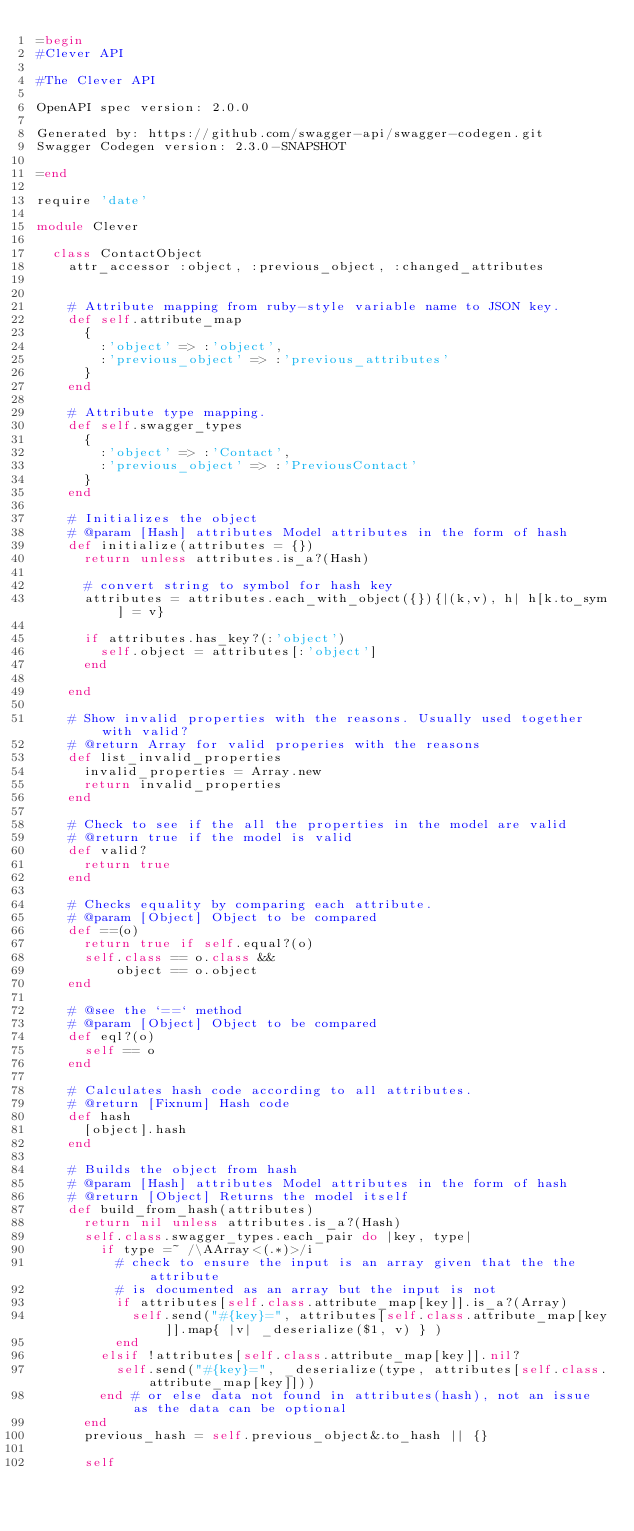<code> <loc_0><loc_0><loc_500><loc_500><_Ruby_>=begin
#Clever API

#The Clever API

OpenAPI spec version: 2.0.0

Generated by: https://github.com/swagger-api/swagger-codegen.git
Swagger Codegen version: 2.3.0-SNAPSHOT

=end

require 'date'

module Clever

  class ContactObject
    attr_accessor :object, :previous_object, :changed_attributes


    # Attribute mapping from ruby-style variable name to JSON key.
    def self.attribute_map
      {
        :'object' => :'object',
        :'previous_object' => :'previous_attributes'
      }
    end

    # Attribute type mapping.
    def self.swagger_types
      {
        :'object' => :'Contact',
        :'previous_object' => :'PreviousContact'
      }
    end

    # Initializes the object
    # @param [Hash] attributes Model attributes in the form of hash
    def initialize(attributes = {})
      return unless attributes.is_a?(Hash)

      # convert string to symbol for hash key
      attributes = attributes.each_with_object({}){|(k,v), h| h[k.to_sym] = v}

      if attributes.has_key?(:'object')
        self.object = attributes[:'object']
      end

    end

    # Show invalid properties with the reasons. Usually used together with valid?
    # @return Array for valid properies with the reasons
    def list_invalid_properties
      invalid_properties = Array.new
      return invalid_properties
    end

    # Check to see if the all the properties in the model are valid
    # @return true if the model is valid
    def valid?
      return true
    end

    # Checks equality by comparing each attribute.
    # @param [Object] Object to be compared
    def ==(o)
      return true if self.equal?(o)
      self.class == o.class &&
          object == o.object
    end

    # @see the `==` method
    # @param [Object] Object to be compared
    def eql?(o)
      self == o
    end

    # Calculates hash code according to all attributes.
    # @return [Fixnum] Hash code
    def hash
      [object].hash
    end

    # Builds the object from hash
    # @param [Hash] attributes Model attributes in the form of hash
    # @return [Object] Returns the model itself
    def build_from_hash(attributes)
      return nil unless attributes.is_a?(Hash)
      self.class.swagger_types.each_pair do |key, type|
        if type =~ /\AArray<(.*)>/i
          # check to ensure the input is an array given that the the attribute
          # is documented as an array but the input is not
          if attributes[self.class.attribute_map[key]].is_a?(Array)
            self.send("#{key}=", attributes[self.class.attribute_map[key]].map{ |v| _deserialize($1, v) } )
          end
        elsif !attributes[self.class.attribute_map[key]].nil?
          self.send("#{key}=", _deserialize(type, attributes[self.class.attribute_map[key]]))
        end # or else data not found in attributes(hash), not an issue as the data can be optional
      end
      previous_hash = self.previous_object&.to_hash || {}

      self</code> 